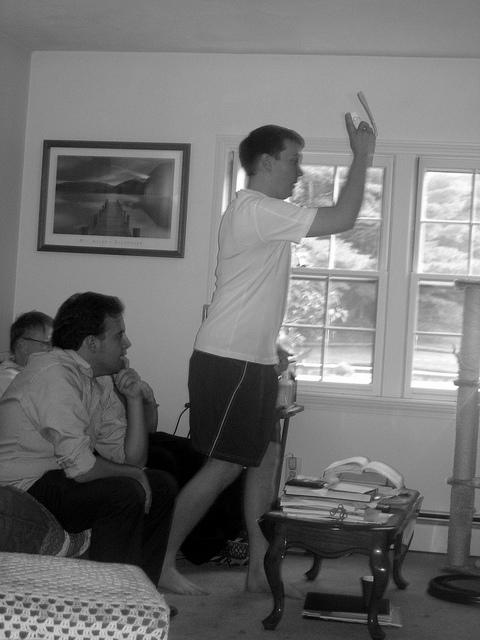What are the men doing?
Give a very brief answer. Playing wii. What type of game is this person playing?
Give a very brief answer. Wii. Is there a recycling bin in this image?
Short answer required. No. How many windows are in the picture?
Short answer required. 2. How many people are playing a video game?
Keep it brief. 3. Are all the seats occupied?
Short answer required. No. Who is barefooted?
Quick response, please. Man standing. 